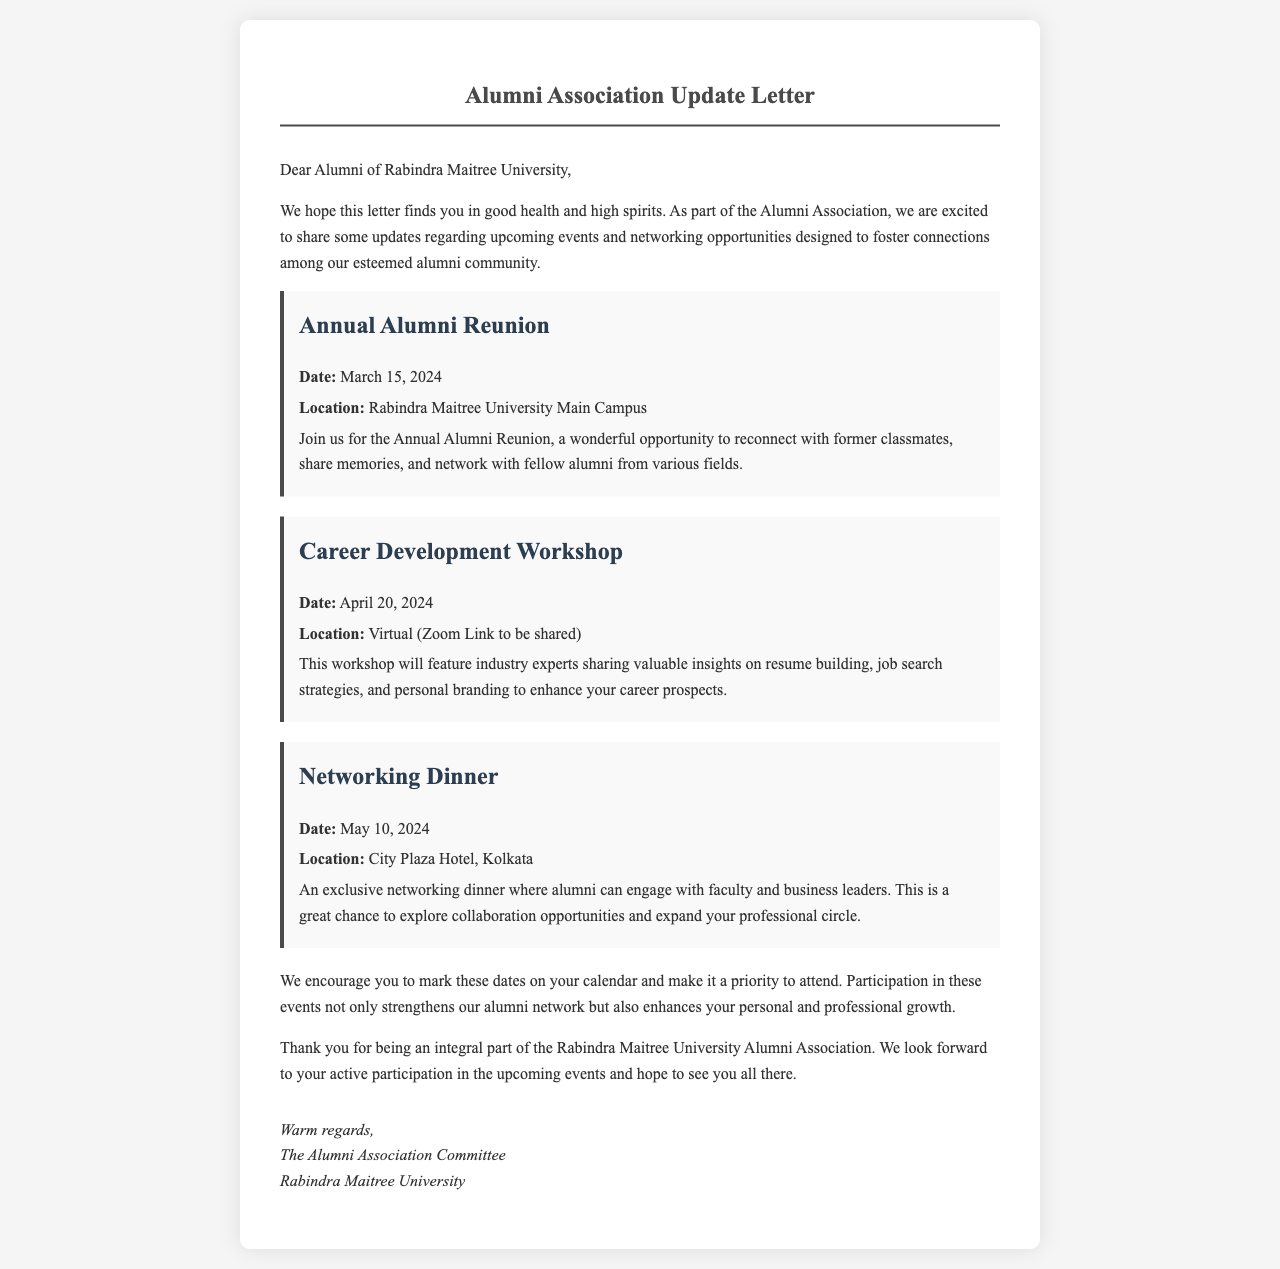What is the date of the Annual Alumni Reunion? The letter specifies the date of the Annual Alumni Reunion as March 15, 2024.
Answer: March 15, 2024 Where will the Career Development Workshop be held? The letter states that the Career Development Workshop will be held virtually.
Answer: Virtual What is the location of the Networking Dinner? The letter mentions that the Networking Dinner will take place at City Plaza Hotel, Kolkata.
Answer: City Plaza Hotel, Kolkata Who is hosting the events mentioned in the letter? The letter indicates that the events are hosted by the Alumni Association Committee.
Answer: Alumni Association Committee What is the primary purpose of the events listed in the letter? The letter highlights that the purpose is to foster connections among alumni and enhance personal and professional growth.
Answer: Foster connections and enhance growth How many events are mentioned in the letter? The letter outlines three different events scheduled for alumni.
Answer: Three 